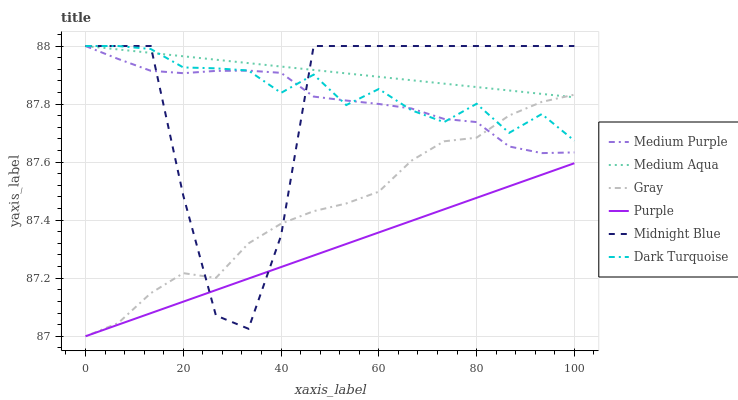Does Purple have the minimum area under the curve?
Answer yes or no. Yes. Does Medium Aqua have the maximum area under the curve?
Answer yes or no. Yes. Does Midnight Blue have the minimum area under the curve?
Answer yes or no. No. Does Midnight Blue have the maximum area under the curve?
Answer yes or no. No. Is Purple the smoothest?
Answer yes or no. Yes. Is Midnight Blue the roughest?
Answer yes or no. Yes. Is Midnight Blue the smoothest?
Answer yes or no. No. Is Purple the roughest?
Answer yes or no. No. Does Gray have the lowest value?
Answer yes or no. Yes. Does Midnight Blue have the lowest value?
Answer yes or no. No. Does Medium Aqua have the highest value?
Answer yes or no. Yes. Does Purple have the highest value?
Answer yes or no. No. Is Purple less than Dark Turquoise?
Answer yes or no. Yes. Is Dark Turquoise greater than Purple?
Answer yes or no. Yes. Does Dark Turquoise intersect Medium Purple?
Answer yes or no. Yes. Is Dark Turquoise less than Medium Purple?
Answer yes or no. No. Is Dark Turquoise greater than Medium Purple?
Answer yes or no. No. Does Purple intersect Dark Turquoise?
Answer yes or no. No. 